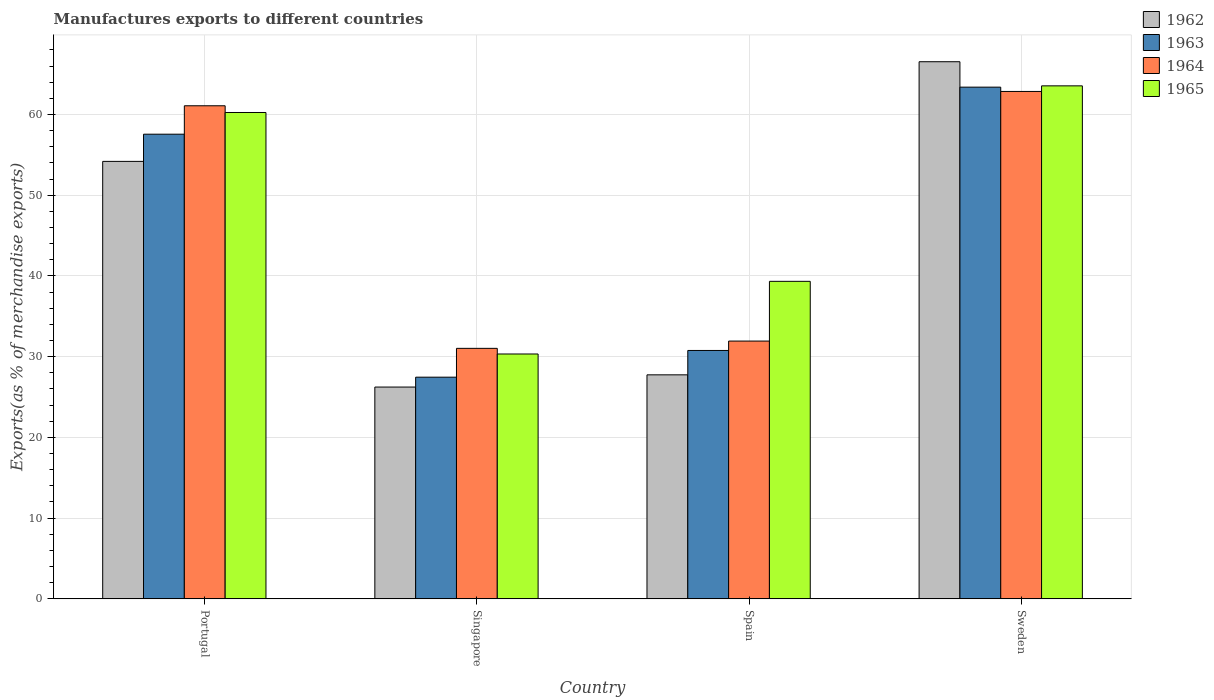How many groups of bars are there?
Your answer should be compact. 4. Are the number of bars per tick equal to the number of legend labels?
Provide a short and direct response. Yes. How many bars are there on the 1st tick from the left?
Offer a very short reply. 4. How many bars are there on the 1st tick from the right?
Keep it short and to the point. 4. What is the label of the 1st group of bars from the left?
Your answer should be compact. Portugal. What is the percentage of exports to different countries in 1964 in Spain?
Offer a very short reply. 31.93. Across all countries, what is the maximum percentage of exports to different countries in 1964?
Keep it short and to the point. 62.86. Across all countries, what is the minimum percentage of exports to different countries in 1964?
Your response must be concise. 31.03. In which country was the percentage of exports to different countries in 1965 maximum?
Offer a terse response. Sweden. In which country was the percentage of exports to different countries in 1963 minimum?
Ensure brevity in your answer.  Singapore. What is the total percentage of exports to different countries in 1965 in the graph?
Your response must be concise. 193.46. What is the difference between the percentage of exports to different countries in 1962 in Portugal and that in Sweden?
Offer a very short reply. -12.35. What is the difference between the percentage of exports to different countries in 1965 in Sweden and the percentage of exports to different countries in 1963 in Spain?
Ensure brevity in your answer.  32.78. What is the average percentage of exports to different countries in 1962 per country?
Keep it short and to the point. 43.68. What is the difference between the percentage of exports to different countries of/in 1964 and percentage of exports to different countries of/in 1965 in Singapore?
Your answer should be very brief. 0.7. What is the ratio of the percentage of exports to different countries in 1963 in Portugal to that in Singapore?
Provide a succinct answer. 2.1. Is the difference between the percentage of exports to different countries in 1964 in Portugal and Singapore greater than the difference between the percentage of exports to different countries in 1965 in Portugal and Singapore?
Keep it short and to the point. Yes. What is the difference between the highest and the second highest percentage of exports to different countries in 1964?
Your answer should be compact. -1.77. What is the difference between the highest and the lowest percentage of exports to different countries in 1962?
Offer a very short reply. 40.3. In how many countries, is the percentage of exports to different countries in 1964 greater than the average percentage of exports to different countries in 1964 taken over all countries?
Ensure brevity in your answer.  2. Is it the case that in every country, the sum of the percentage of exports to different countries in 1964 and percentage of exports to different countries in 1962 is greater than the sum of percentage of exports to different countries in 1963 and percentage of exports to different countries in 1965?
Ensure brevity in your answer.  No. What does the 3rd bar from the left in Portugal represents?
Offer a very short reply. 1964. What does the 4th bar from the right in Singapore represents?
Your answer should be very brief. 1962. Is it the case that in every country, the sum of the percentage of exports to different countries in 1964 and percentage of exports to different countries in 1965 is greater than the percentage of exports to different countries in 1963?
Ensure brevity in your answer.  Yes. How many bars are there?
Give a very brief answer. 16. Are all the bars in the graph horizontal?
Your answer should be compact. No. Are the values on the major ticks of Y-axis written in scientific E-notation?
Your answer should be compact. No. Does the graph contain any zero values?
Offer a terse response. No. Does the graph contain grids?
Keep it short and to the point. Yes. How are the legend labels stacked?
Your response must be concise. Vertical. What is the title of the graph?
Make the answer very short. Manufactures exports to different countries. Does "1979" appear as one of the legend labels in the graph?
Keep it short and to the point. No. What is the label or title of the X-axis?
Your answer should be compact. Country. What is the label or title of the Y-axis?
Offer a terse response. Exports(as % of merchandise exports). What is the Exports(as % of merchandise exports) of 1962 in Portugal?
Provide a succinct answer. 54.19. What is the Exports(as % of merchandise exports) of 1963 in Portugal?
Offer a terse response. 57.56. What is the Exports(as % of merchandise exports) of 1964 in Portugal?
Your answer should be compact. 61.08. What is the Exports(as % of merchandise exports) in 1965 in Portugal?
Keep it short and to the point. 60.25. What is the Exports(as % of merchandise exports) of 1962 in Singapore?
Your answer should be compact. 26.24. What is the Exports(as % of merchandise exports) of 1963 in Singapore?
Make the answer very short. 27.46. What is the Exports(as % of merchandise exports) in 1964 in Singapore?
Your answer should be compact. 31.03. What is the Exports(as % of merchandise exports) of 1965 in Singapore?
Provide a succinct answer. 30.33. What is the Exports(as % of merchandise exports) in 1962 in Spain?
Give a very brief answer. 27.75. What is the Exports(as % of merchandise exports) in 1963 in Spain?
Provide a succinct answer. 30.77. What is the Exports(as % of merchandise exports) in 1964 in Spain?
Provide a short and direct response. 31.93. What is the Exports(as % of merchandise exports) in 1965 in Spain?
Offer a very short reply. 39.33. What is the Exports(as % of merchandise exports) of 1962 in Sweden?
Provide a succinct answer. 66.54. What is the Exports(as % of merchandise exports) in 1963 in Sweden?
Your answer should be compact. 63.39. What is the Exports(as % of merchandise exports) in 1964 in Sweden?
Offer a very short reply. 62.86. What is the Exports(as % of merchandise exports) in 1965 in Sweden?
Provide a short and direct response. 63.55. Across all countries, what is the maximum Exports(as % of merchandise exports) of 1962?
Provide a short and direct response. 66.54. Across all countries, what is the maximum Exports(as % of merchandise exports) in 1963?
Offer a very short reply. 63.39. Across all countries, what is the maximum Exports(as % of merchandise exports) of 1964?
Ensure brevity in your answer.  62.86. Across all countries, what is the maximum Exports(as % of merchandise exports) in 1965?
Make the answer very short. 63.55. Across all countries, what is the minimum Exports(as % of merchandise exports) of 1962?
Your answer should be very brief. 26.24. Across all countries, what is the minimum Exports(as % of merchandise exports) of 1963?
Keep it short and to the point. 27.46. Across all countries, what is the minimum Exports(as % of merchandise exports) of 1964?
Ensure brevity in your answer.  31.03. Across all countries, what is the minimum Exports(as % of merchandise exports) of 1965?
Provide a short and direct response. 30.33. What is the total Exports(as % of merchandise exports) in 1962 in the graph?
Provide a short and direct response. 174.72. What is the total Exports(as % of merchandise exports) in 1963 in the graph?
Ensure brevity in your answer.  179.18. What is the total Exports(as % of merchandise exports) of 1964 in the graph?
Keep it short and to the point. 186.9. What is the total Exports(as % of merchandise exports) in 1965 in the graph?
Your answer should be compact. 193.46. What is the difference between the Exports(as % of merchandise exports) of 1962 in Portugal and that in Singapore?
Give a very brief answer. 27.96. What is the difference between the Exports(as % of merchandise exports) in 1963 in Portugal and that in Singapore?
Offer a very short reply. 30.1. What is the difference between the Exports(as % of merchandise exports) in 1964 in Portugal and that in Singapore?
Your response must be concise. 30.05. What is the difference between the Exports(as % of merchandise exports) of 1965 in Portugal and that in Singapore?
Your response must be concise. 29.92. What is the difference between the Exports(as % of merchandise exports) in 1962 in Portugal and that in Spain?
Offer a terse response. 26.44. What is the difference between the Exports(as % of merchandise exports) in 1963 in Portugal and that in Spain?
Offer a very short reply. 26.79. What is the difference between the Exports(as % of merchandise exports) in 1964 in Portugal and that in Spain?
Offer a terse response. 29.15. What is the difference between the Exports(as % of merchandise exports) of 1965 in Portugal and that in Spain?
Make the answer very short. 20.92. What is the difference between the Exports(as % of merchandise exports) of 1962 in Portugal and that in Sweden?
Your response must be concise. -12.35. What is the difference between the Exports(as % of merchandise exports) of 1963 in Portugal and that in Sweden?
Your answer should be very brief. -5.83. What is the difference between the Exports(as % of merchandise exports) in 1964 in Portugal and that in Sweden?
Offer a very short reply. -1.77. What is the difference between the Exports(as % of merchandise exports) in 1965 in Portugal and that in Sweden?
Offer a terse response. -3.3. What is the difference between the Exports(as % of merchandise exports) in 1962 in Singapore and that in Spain?
Your response must be concise. -1.51. What is the difference between the Exports(as % of merchandise exports) in 1963 in Singapore and that in Spain?
Your response must be concise. -3.31. What is the difference between the Exports(as % of merchandise exports) of 1964 in Singapore and that in Spain?
Ensure brevity in your answer.  -0.9. What is the difference between the Exports(as % of merchandise exports) in 1965 in Singapore and that in Spain?
Your answer should be compact. -9. What is the difference between the Exports(as % of merchandise exports) in 1962 in Singapore and that in Sweden?
Keep it short and to the point. -40.3. What is the difference between the Exports(as % of merchandise exports) in 1963 in Singapore and that in Sweden?
Offer a terse response. -35.93. What is the difference between the Exports(as % of merchandise exports) in 1964 in Singapore and that in Sweden?
Provide a succinct answer. -31.83. What is the difference between the Exports(as % of merchandise exports) of 1965 in Singapore and that in Sweden?
Your answer should be compact. -33.22. What is the difference between the Exports(as % of merchandise exports) of 1962 in Spain and that in Sweden?
Provide a short and direct response. -38.79. What is the difference between the Exports(as % of merchandise exports) in 1963 in Spain and that in Sweden?
Your answer should be very brief. -32.62. What is the difference between the Exports(as % of merchandise exports) of 1964 in Spain and that in Sweden?
Ensure brevity in your answer.  -30.92. What is the difference between the Exports(as % of merchandise exports) in 1965 in Spain and that in Sweden?
Your answer should be compact. -24.22. What is the difference between the Exports(as % of merchandise exports) of 1962 in Portugal and the Exports(as % of merchandise exports) of 1963 in Singapore?
Make the answer very short. 26.73. What is the difference between the Exports(as % of merchandise exports) in 1962 in Portugal and the Exports(as % of merchandise exports) in 1964 in Singapore?
Offer a terse response. 23.16. What is the difference between the Exports(as % of merchandise exports) of 1962 in Portugal and the Exports(as % of merchandise exports) of 1965 in Singapore?
Your response must be concise. 23.86. What is the difference between the Exports(as % of merchandise exports) of 1963 in Portugal and the Exports(as % of merchandise exports) of 1964 in Singapore?
Provide a succinct answer. 26.53. What is the difference between the Exports(as % of merchandise exports) in 1963 in Portugal and the Exports(as % of merchandise exports) in 1965 in Singapore?
Your answer should be compact. 27.23. What is the difference between the Exports(as % of merchandise exports) in 1964 in Portugal and the Exports(as % of merchandise exports) in 1965 in Singapore?
Keep it short and to the point. 30.75. What is the difference between the Exports(as % of merchandise exports) of 1962 in Portugal and the Exports(as % of merchandise exports) of 1963 in Spain?
Ensure brevity in your answer.  23.42. What is the difference between the Exports(as % of merchandise exports) of 1962 in Portugal and the Exports(as % of merchandise exports) of 1964 in Spain?
Your answer should be very brief. 22.26. What is the difference between the Exports(as % of merchandise exports) of 1962 in Portugal and the Exports(as % of merchandise exports) of 1965 in Spain?
Your answer should be very brief. 14.86. What is the difference between the Exports(as % of merchandise exports) in 1963 in Portugal and the Exports(as % of merchandise exports) in 1964 in Spain?
Your answer should be very brief. 25.63. What is the difference between the Exports(as % of merchandise exports) in 1963 in Portugal and the Exports(as % of merchandise exports) in 1965 in Spain?
Ensure brevity in your answer.  18.23. What is the difference between the Exports(as % of merchandise exports) of 1964 in Portugal and the Exports(as % of merchandise exports) of 1965 in Spain?
Give a very brief answer. 21.75. What is the difference between the Exports(as % of merchandise exports) of 1962 in Portugal and the Exports(as % of merchandise exports) of 1963 in Sweden?
Your response must be concise. -9.2. What is the difference between the Exports(as % of merchandise exports) of 1962 in Portugal and the Exports(as % of merchandise exports) of 1964 in Sweden?
Your response must be concise. -8.66. What is the difference between the Exports(as % of merchandise exports) of 1962 in Portugal and the Exports(as % of merchandise exports) of 1965 in Sweden?
Ensure brevity in your answer.  -9.36. What is the difference between the Exports(as % of merchandise exports) of 1963 in Portugal and the Exports(as % of merchandise exports) of 1964 in Sweden?
Provide a succinct answer. -5.3. What is the difference between the Exports(as % of merchandise exports) in 1963 in Portugal and the Exports(as % of merchandise exports) in 1965 in Sweden?
Your answer should be very brief. -5.99. What is the difference between the Exports(as % of merchandise exports) of 1964 in Portugal and the Exports(as % of merchandise exports) of 1965 in Sweden?
Offer a terse response. -2.47. What is the difference between the Exports(as % of merchandise exports) in 1962 in Singapore and the Exports(as % of merchandise exports) in 1963 in Spain?
Make the answer very short. -4.53. What is the difference between the Exports(as % of merchandise exports) of 1962 in Singapore and the Exports(as % of merchandise exports) of 1964 in Spain?
Keep it short and to the point. -5.7. What is the difference between the Exports(as % of merchandise exports) in 1962 in Singapore and the Exports(as % of merchandise exports) in 1965 in Spain?
Provide a short and direct response. -13.1. What is the difference between the Exports(as % of merchandise exports) in 1963 in Singapore and the Exports(as % of merchandise exports) in 1964 in Spain?
Provide a short and direct response. -4.47. What is the difference between the Exports(as % of merchandise exports) of 1963 in Singapore and the Exports(as % of merchandise exports) of 1965 in Spain?
Provide a short and direct response. -11.87. What is the difference between the Exports(as % of merchandise exports) in 1964 in Singapore and the Exports(as % of merchandise exports) in 1965 in Spain?
Offer a very short reply. -8.3. What is the difference between the Exports(as % of merchandise exports) in 1962 in Singapore and the Exports(as % of merchandise exports) in 1963 in Sweden?
Provide a succinct answer. -37.15. What is the difference between the Exports(as % of merchandise exports) of 1962 in Singapore and the Exports(as % of merchandise exports) of 1964 in Sweden?
Provide a succinct answer. -36.62. What is the difference between the Exports(as % of merchandise exports) of 1962 in Singapore and the Exports(as % of merchandise exports) of 1965 in Sweden?
Your response must be concise. -37.31. What is the difference between the Exports(as % of merchandise exports) of 1963 in Singapore and the Exports(as % of merchandise exports) of 1964 in Sweden?
Provide a short and direct response. -35.4. What is the difference between the Exports(as % of merchandise exports) in 1963 in Singapore and the Exports(as % of merchandise exports) in 1965 in Sweden?
Give a very brief answer. -36.09. What is the difference between the Exports(as % of merchandise exports) in 1964 in Singapore and the Exports(as % of merchandise exports) in 1965 in Sweden?
Provide a short and direct response. -32.52. What is the difference between the Exports(as % of merchandise exports) of 1962 in Spain and the Exports(as % of merchandise exports) of 1963 in Sweden?
Make the answer very short. -35.64. What is the difference between the Exports(as % of merchandise exports) of 1962 in Spain and the Exports(as % of merchandise exports) of 1964 in Sweden?
Keep it short and to the point. -35.11. What is the difference between the Exports(as % of merchandise exports) of 1962 in Spain and the Exports(as % of merchandise exports) of 1965 in Sweden?
Give a very brief answer. -35.8. What is the difference between the Exports(as % of merchandise exports) of 1963 in Spain and the Exports(as % of merchandise exports) of 1964 in Sweden?
Make the answer very short. -32.09. What is the difference between the Exports(as % of merchandise exports) of 1963 in Spain and the Exports(as % of merchandise exports) of 1965 in Sweden?
Provide a succinct answer. -32.78. What is the difference between the Exports(as % of merchandise exports) in 1964 in Spain and the Exports(as % of merchandise exports) in 1965 in Sweden?
Provide a short and direct response. -31.62. What is the average Exports(as % of merchandise exports) in 1962 per country?
Ensure brevity in your answer.  43.68. What is the average Exports(as % of merchandise exports) of 1963 per country?
Keep it short and to the point. 44.79. What is the average Exports(as % of merchandise exports) in 1964 per country?
Provide a succinct answer. 46.73. What is the average Exports(as % of merchandise exports) in 1965 per country?
Offer a terse response. 48.37. What is the difference between the Exports(as % of merchandise exports) of 1962 and Exports(as % of merchandise exports) of 1963 in Portugal?
Provide a succinct answer. -3.37. What is the difference between the Exports(as % of merchandise exports) in 1962 and Exports(as % of merchandise exports) in 1964 in Portugal?
Offer a very short reply. -6.89. What is the difference between the Exports(as % of merchandise exports) in 1962 and Exports(as % of merchandise exports) in 1965 in Portugal?
Your response must be concise. -6.06. What is the difference between the Exports(as % of merchandise exports) of 1963 and Exports(as % of merchandise exports) of 1964 in Portugal?
Offer a very short reply. -3.52. What is the difference between the Exports(as % of merchandise exports) of 1963 and Exports(as % of merchandise exports) of 1965 in Portugal?
Provide a short and direct response. -2.69. What is the difference between the Exports(as % of merchandise exports) of 1964 and Exports(as % of merchandise exports) of 1965 in Portugal?
Offer a very short reply. 0.83. What is the difference between the Exports(as % of merchandise exports) of 1962 and Exports(as % of merchandise exports) of 1963 in Singapore?
Offer a very short reply. -1.22. What is the difference between the Exports(as % of merchandise exports) of 1962 and Exports(as % of merchandise exports) of 1964 in Singapore?
Give a very brief answer. -4.79. What is the difference between the Exports(as % of merchandise exports) in 1962 and Exports(as % of merchandise exports) in 1965 in Singapore?
Your response must be concise. -4.1. What is the difference between the Exports(as % of merchandise exports) of 1963 and Exports(as % of merchandise exports) of 1964 in Singapore?
Provide a short and direct response. -3.57. What is the difference between the Exports(as % of merchandise exports) of 1963 and Exports(as % of merchandise exports) of 1965 in Singapore?
Make the answer very short. -2.87. What is the difference between the Exports(as % of merchandise exports) in 1964 and Exports(as % of merchandise exports) in 1965 in Singapore?
Offer a terse response. 0.7. What is the difference between the Exports(as % of merchandise exports) of 1962 and Exports(as % of merchandise exports) of 1963 in Spain?
Your response must be concise. -3.02. What is the difference between the Exports(as % of merchandise exports) of 1962 and Exports(as % of merchandise exports) of 1964 in Spain?
Ensure brevity in your answer.  -4.18. What is the difference between the Exports(as % of merchandise exports) of 1962 and Exports(as % of merchandise exports) of 1965 in Spain?
Provide a succinct answer. -11.58. What is the difference between the Exports(as % of merchandise exports) of 1963 and Exports(as % of merchandise exports) of 1964 in Spain?
Provide a succinct answer. -1.16. What is the difference between the Exports(as % of merchandise exports) of 1963 and Exports(as % of merchandise exports) of 1965 in Spain?
Ensure brevity in your answer.  -8.56. What is the difference between the Exports(as % of merchandise exports) of 1964 and Exports(as % of merchandise exports) of 1965 in Spain?
Provide a short and direct response. -7.4. What is the difference between the Exports(as % of merchandise exports) of 1962 and Exports(as % of merchandise exports) of 1963 in Sweden?
Your answer should be very brief. 3.15. What is the difference between the Exports(as % of merchandise exports) of 1962 and Exports(as % of merchandise exports) of 1964 in Sweden?
Offer a terse response. 3.68. What is the difference between the Exports(as % of merchandise exports) of 1962 and Exports(as % of merchandise exports) of 1965 in Sweden?
Your response must be concise. 2.99. What is the difference between the Exports(as % of merchandise exports) of 1963 and Exports(as % of merchandise exports) of 1964 in Sweden?
Your answer should be compact. 0.53. What is the difference between the Exports(as % of merchandise exports) in 1963 and Exports(as % of merchandise exports) in 1965 in Sweden?
Ensure brevity in your answer.  -0.16. What is the difference between the Exports(as % of merchandise exports) of 1964 and Exports(as % of merchandise exports) of 1965 in Sweden?
Your answer should be compact. -0.69. What is the ratio of the Exports(as % of merchandise exports) in 1962 in Portugal to that in Singapore?
Keep it short and to the point. 2.07. What is the ratio of the Exports(as % of merchandise exports) of 1963 in Portugal to that in Singapore?
Your response must be concise. 2.1. What is the ratio of the Exports(as % of merchandise exports) in 1964 in Portugal to that in Singapore?
Ensure brevity in your answer.  1.97. What is the ratio of the Exports(as % of merchandise exports) in 1965 in Portugal to that in Singapore?
Offer a very short reply. 1.99. What is the ratio of the Exports(as % of merchandise exports) of 1962 in Portugal to that in Spain?
Provide a short and direct response. 1.95. What is the ratio of the Exports(as % of merchandise exports) of 1963 in Portugal to that in Spain?
Offer a terse response. 1.87. What is the ratio of the Exports(as % of merchandise exports) of 1964 in Portugal to that in Spain?
Provide a succinct answer. 1.91. What is the ratio of the Exports(as % of merchandise exports) of 1965 in Portugal to that in Spain?
Your answer should be very brief. 1.53. What is the ratio of the Exports(as % of merchandise exports) in 1962 in Portugal to that in Sweden?
Keep it short and to the point. 0.81. What is the ratio of the Exports(as % of merchandise exports) of 1963 in Portugal to that in Sweden?
Give a very brief answer. 0.91. What is the ratio of the Exports(as % of merchandise exports) of 1964 in Portugal to that in Sweden?
Make the answer very short. 0.97. What is the ratio of the Exports(as % of merchandise exports) in 1965 in Portugal to that in Sweden?
Give a very brief answer. 0.95. What is the ratio of the Exports(as % of merchandise exports) in 1962 in Singapore to that in Spain?
Your answer should be compact. 0.95. What is the ratio of the Exports(as % of merchandise exports) in 1963 in Singapore to that in Spain?
Your answer should be compact. 0.89. What is the ratio of the Exports(as % of merchandise exports) in 1964 in Singapore to that in Spain?
Provide a short and direct response. 0.97. What is the ratio of the Exports(as % of merchandise exports) of 1965 in Singapore to that in Spain?
Offer a very short reply. 0.77. What is the ratio of the Exports(as % of merchandise exports) in 1962 in Singapore to that in Sweden?
Keep it short and to the point. 0.39. What is the ratio of the Exports(as % of merchandise exports) in 1963 in Singapore to that in Sweden?
Your response must be concise. 0.43. What is the ratio of the Exports(as % of merchandise exports) of 1964 in Singapore to that in Sweden?
Keep it short and to the point. 0.49. What is the ratio of the Exports(as % of merchandise exports) in 1965 in Singapore to that in Sweden?
Provide a succinct answer. 0.48. What is the ratio of the Exports(as % of merchandise exports) in 1962 in Spain to that in Sweden?
Provide a succinct answer. 0.42. What is the ratio of the Exports(as % of merchandise exports) of 1963 in Spain to that in Sweden?
Keep it short and to the point. 0.49. What is the ratio of the Exports(as % of merchandise exports) in 1964 in Spain to that in Sweden?
Ensure brevity in your answer.  0.51. What is the ratio of the Exports(as % of merchandise exports) in 1965 in Spain to that in Sweden?
Make the answer very short. 0.62. What is the difference between the highest and the second highest Exports(as % of merchandise exports) of 1962?
Keep it short and to the point. 12.35. What is the difference between the highest and the second highest Exports(as % of merchandise exports) of 1963?
Provide a short and direct response. 5.83. What is the difference between the highest and the second highest Exports(as % of merchandise exports) of 1964?
Offer a very short reply. 1.77. What is the difference between the highest and the second highest Exports(as % of merchandise exports) in 1965?
Your response must be concise. 3.3. What is the difference between the highest and the lowest Exports(as % of merchandise exports) of 1962?
Give a very brief answer. 40.3. What is the difference between the highest and the lowest Exports(as % of merchandise exports) in 1963?
Make the answer very short. 35.93. What is the difference between the highest and the lowest Exports(as % of merchandise exports) of 1964?
Give a very brief answer. 31.83. What is the difference between the highest and the lowest Exports(as % of merchandise exports) in 1965?
Provide a succinct answer. 33.22. 